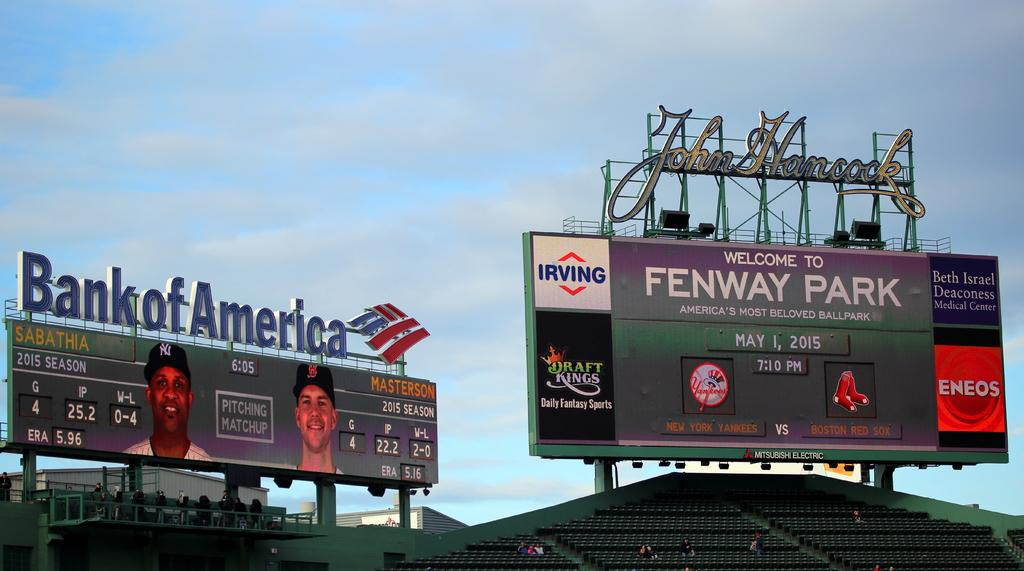<image>
Share a concise interpretation of the image provided. The signature of John Hancock hangs over a Fenway Park sign. 